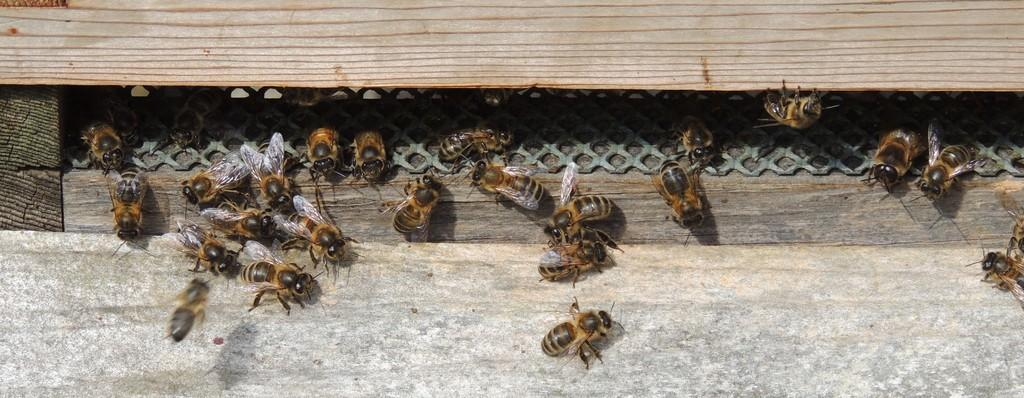What colors are the bees in the image? The bees in the image are black and brown in color. How many giants can be seen interacting with the bees in the image? There are no giants present in the image; it features only bees. What type of tongue can be seen in the image? There is no tongue present in the image; it features only bees. 